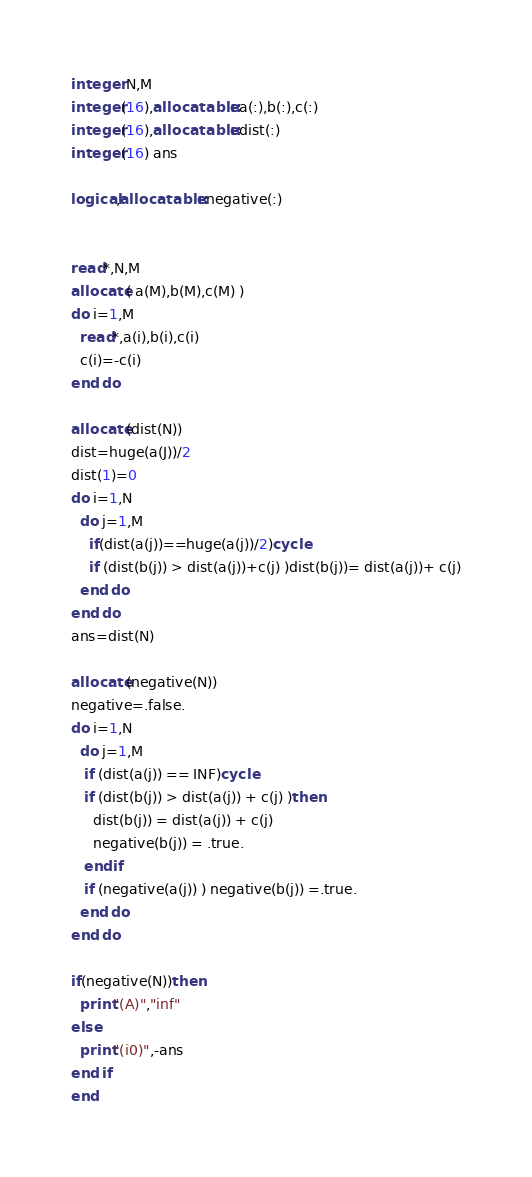<code> <loc_0><loc_0><loc_500><loc_500><_FORTRAN_>integer N,M
integer(16),allocatable::a(:),b(:),c(:)
integer(16),allocatable::dist(:)
integer(16) ans

logical,allocatable::negative(:)


read*,N,M
allocate( a(M),b(M),c(M) )
do i=1,M
  read*,a(i),b(i),c(i)
  c(i)=-c(i)
end do

allocate(dist(N))
dist=huge(a(J))/2
dist(1)=0
do i=1,N
  do j=1,M
    if(dist(a(j))==huge(a(j))/2)cycle
    if (dist(b(j)) > dist(a(j))+c(j) )dist(b(j))= dist(a(j))+ c(j)
  end do
end do
ans=dist(N)

allocate(negative(N))
negative=.false.
do i=1,N
  do j=1,M
   if (dist(a(j)) == INF)cycle
   if (dist(b(j)) > dist(a(j)) + c(j) )then
     dist(b(j)) = dist(a(j)) + c(j)
     negative(b(j)) = .true.
   endif
   if (negative(a(j)) ) negative(b(j)) =.true.
  end do
end do

if(negative(N))then
  print"(A)","inf"
else
  print"(i0)",-ans
end if
end</code> 